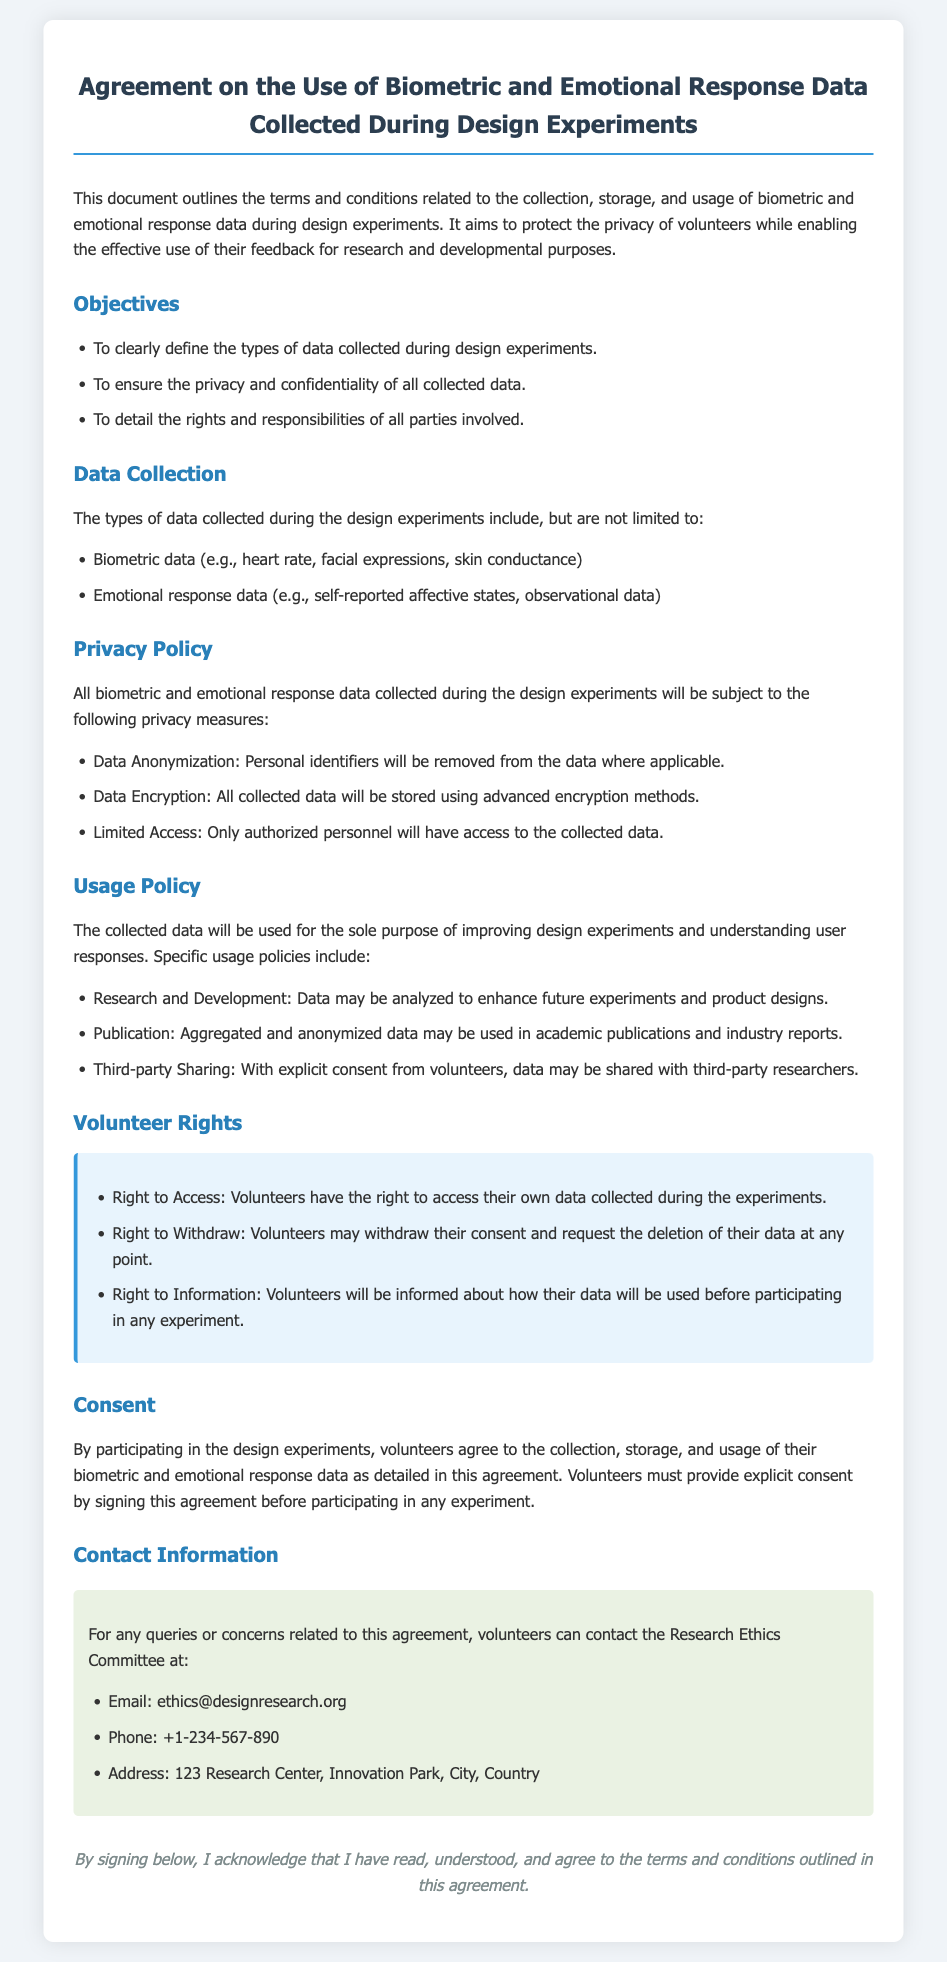What types of data are collected? The document lists the types of data collected during design experiments, which include biometric data and emotional response data.
Answer: Biometric and emotional response data What is the email address for the Research Ethics Committee? The contact information section provides the email address for any queries or concerns related to the agreement.
Answer: ethics@designresearch.org What right do volunteers have regarding their data? The document states several rights of volunteers, including the right to access their own data collected during the experiments.
Answer: Right to Access What kind of data encryption will be used? The privacy policy outlines that all collected data will be stored using advanced encryption methods.
Answer: Advanced encryption methods What is required from volunteers before participating in experiments? The consent section specifies that volunteers must provide explicit consent by signing the agreement before participating.
Answer: Signing this agreement Which data may be shared with third-party researchers? The usage policy outlines that data may be shared with third-party researchers with explicit consent from volunteers.
Answer: Data with explicit consent What will happen if a volunteer withdraws their consent? The document states that volunteers may withdraw their consent and request the deletion of their data at any point.
Answer: Request the deletion of their data What is the main purpose of data collection? The usage policy details that the collected data will be used to improve design experiments and understand user responses.
Answer: Improving design experiments Who will have access to the collected data? The privacy policy notes that only authorized personnel will have access to the collected data.
Answer: Authorized personnel 